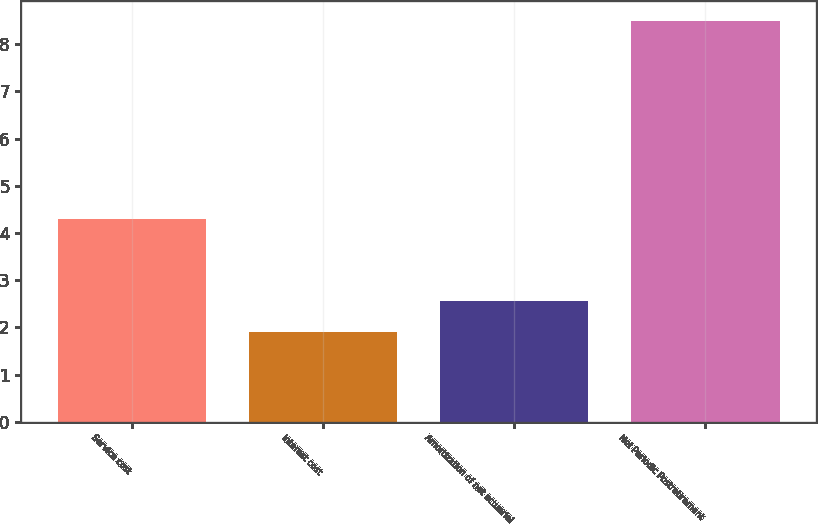<chart> <loc_0><loc_0><loc_500><loc_500><bar_chart><fcel>Service cost<fcel>Interest cost<fcel>Amortization of net actuarial<fcel>Net Periodic Postretirement<nl><fcel>4.3<fcel>1.9<fcel>2.56<fcel>8.5<nl></chart> 